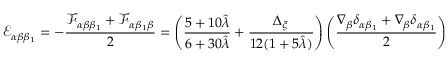Convert formula to latex. <formula><loc_0><loc_0><loc_500><loc_500>\mathcal { E } _ { \alpha \beta \beta _ { 1 } } = - \frac { \mathcal { F } _ { \alpha \beta \beta _ { 1 } } + \mathcal { F } _ { \alpha \beta _ { 1 } \beta } } { 2 } = \left ( \frac { 5 + 1 0 \hat { \lambda } } { 6 + 3 0 \hat { \lambda } } + \frac { \Delta _ { \xi } } { 1 2 ( 1 + 5 \hat { \lambda } ) } \right ) \left ( \frac { \nabla _ { \beta } \delta _ { \alpha \beta _ { 1 } } + \nabla _ { \beta } \delta _ { \alpha \beta _ { 1 } } } { 2 } \right )</formula> 